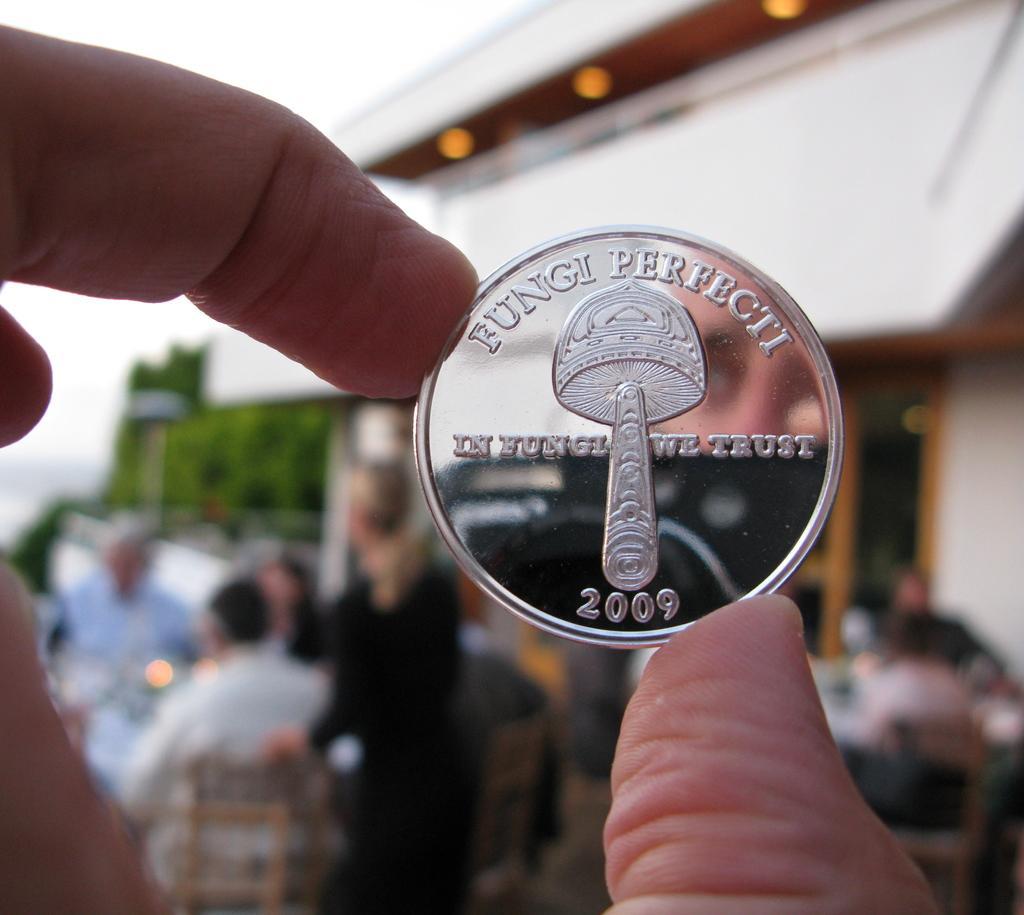In one or two sentences, can you explain what this image depicts? As we can see in the image in the front there is a human hand holding a coin. In the background there is a house, trees and few people sitting on chairs and there is sky. The background is blurred. 